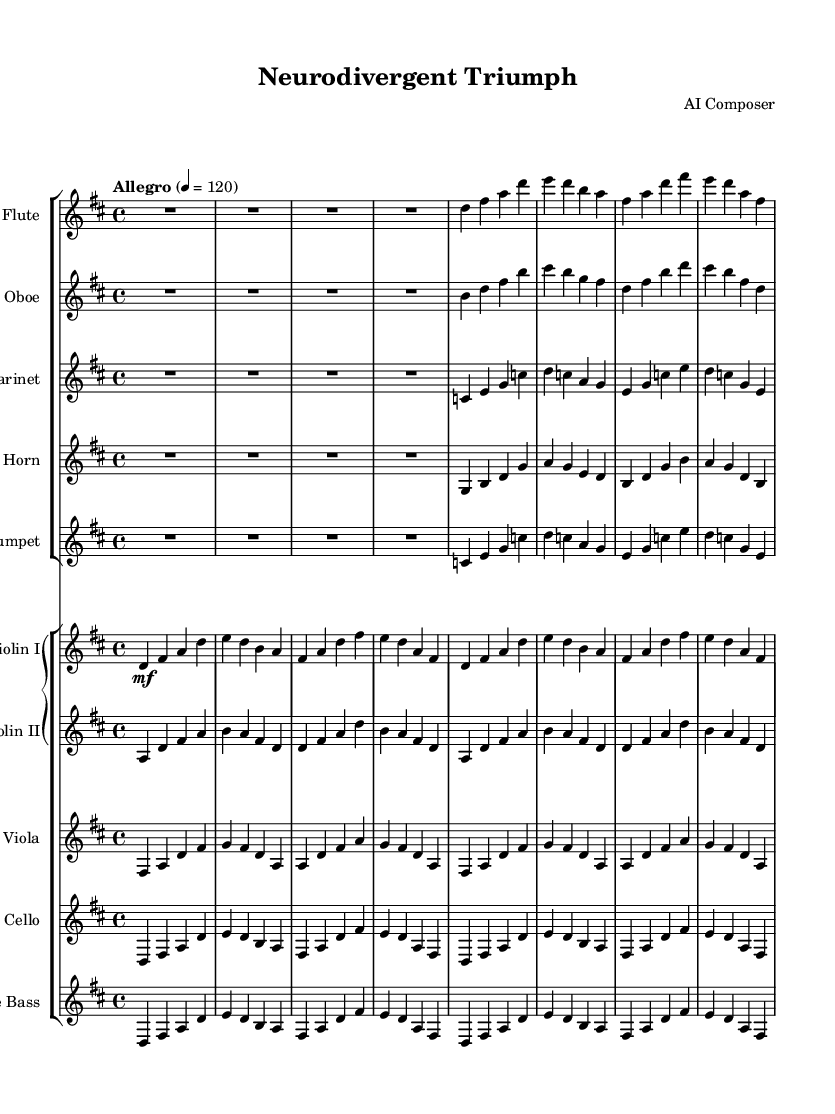What is the key signature of this music? The key signature is D major, which has two sharps (F# and C#). You can identify the key signature in the beginning of the piece.
Answer: D major What is the time signature of this piece? The time signature is 4/4, indicated at the beginning of the score. This means there are four beats in each measure.
Answer: 4/4 What is the tempo marking for this piece? The tempo marking is "Allegro", which indicates a fast and lively tempo. This is also specified at the beginning of the score, along with the metronome marking of quarter note equals 120.
Answer: Allegro How many instruments are used in this orchestral piece? There are eight instruments written in the score, as can be counted in the staff groups presented in the layout. This includes wind, string, and brass instruments.
Answer: Eight Which instrument plays the melody primarily? The violin I is primarily responsible for the melody, as its part contains the most prominent melodic lines and motifs throughout the piece. You can recognize the melody by its prominent placement in the score.
Answer: Violin I What is the dynamic marking for the flute section? The dynamic marking for the flute section is "R1*4", which implies that the flute starts with a rest for the first 4 beats and then plays with no specific dynamic indicated for the subsequent measures, suggesting a moderate volume.
Answer: R1*4 Which section follows the horn in this orchestration? The section that follows the horn in instrumentation order is the trumpet. The trumpet comes after the horn in the score layout, indicating the sequence of the orchestra members.
Answer: Trumpet 